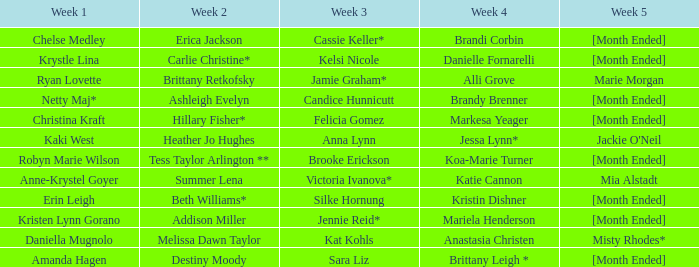What is the first week with candice hunnicutt in the third week? Netty Maj*. 